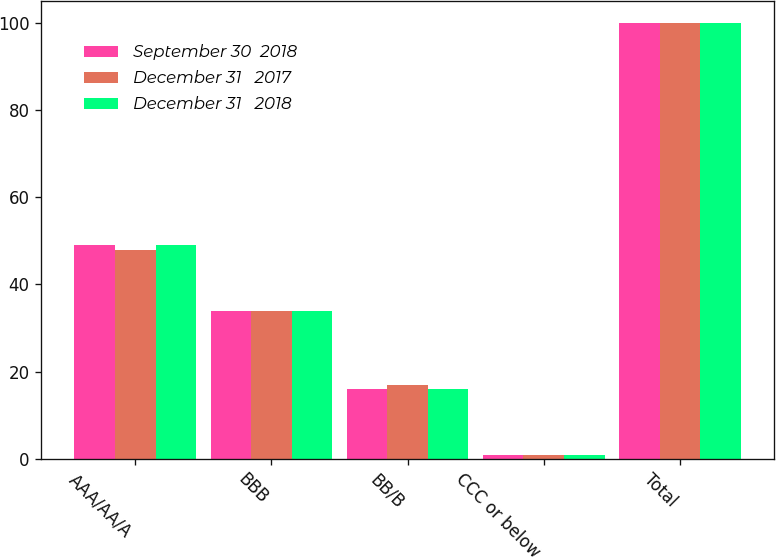Convert chart to OTSL. <chart><loc_0><loc_0><loc_500><loc_500><stacked_bar_chart><ecel><fcel>AAA/AA/A<fcel>BBB<fcel>BB/B<fcel>CCC or below<fcel>Total<nl><fcel>September 30  2018<fcel>49<fcel>34<fcel>16<fcel>1<fcel>100<nl><fcel>December 31   2017<fcel>48<fcel>34<fcel>17<fcel>1<fcel>100<nl><fcel>December 31   2018<fcel>49<fcel>34<fcel>16<fcel>1<fcel>100<nl></chart> 